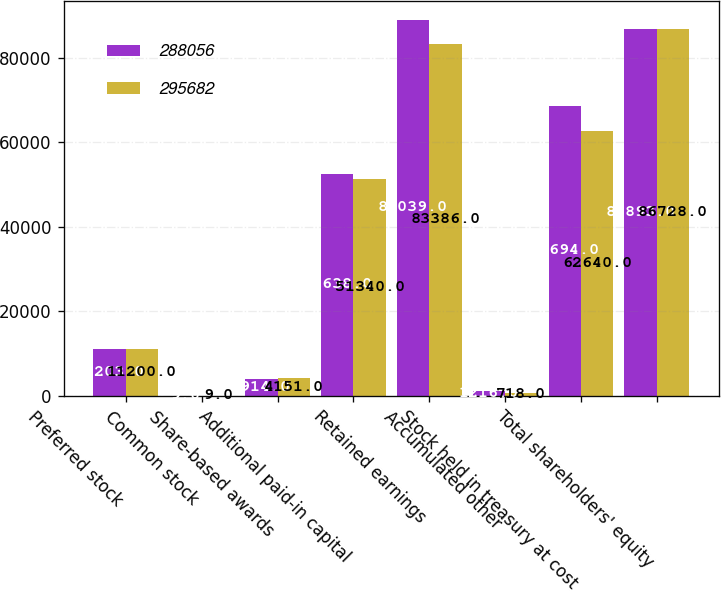Convert chart. <chart><loc_0><loc_0><loc_500><loc_500><stacked_bar_chart><ecel><fcel>Preferred stock<fcel>Common stock<fcel>Share-based awards<fcel>Additional paid-in capital<fcel>Retained earnings<fcel>Accumulated other<fcel>Stock held in treasury at cost<fcel>Total shareholders' equity<nl><fcel>288056<fcel>11203<fcel>9<fcel>3914<fcel>52638<fcel>89039<fcel>1216<fcel>68694<fcel>86893<nl><fcel>295682<fcel>11200<fcel>9<fcel>4151<fcel>51340<fcel>83386<fcel>718<fcel>62640<fcel>86728<nl></chart> 